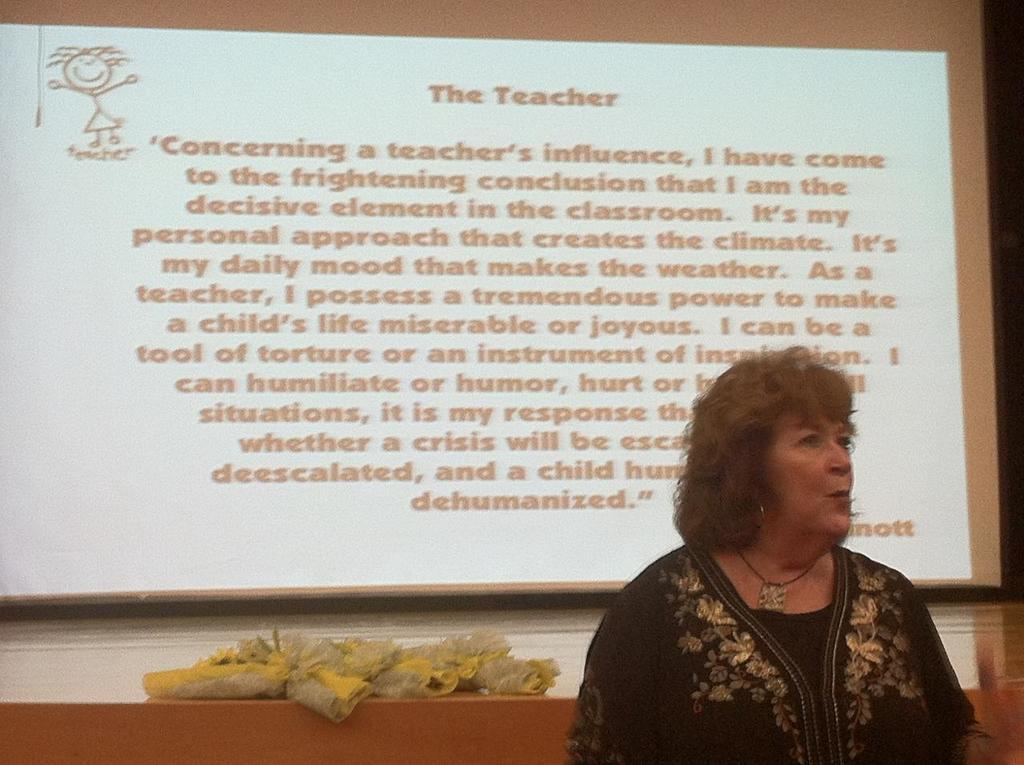Who is present in the image? There is a woman in the image. What can be seen in the background of the image? There is a screen on a board in the background of the image. What is the price of the horse in the image? There is no horse present in the image, so it is not possible to determine its price. 